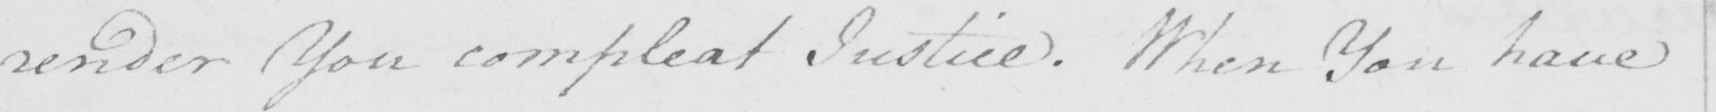Please provide the text content of this handwritten line. render You compleat Justice . When You have 